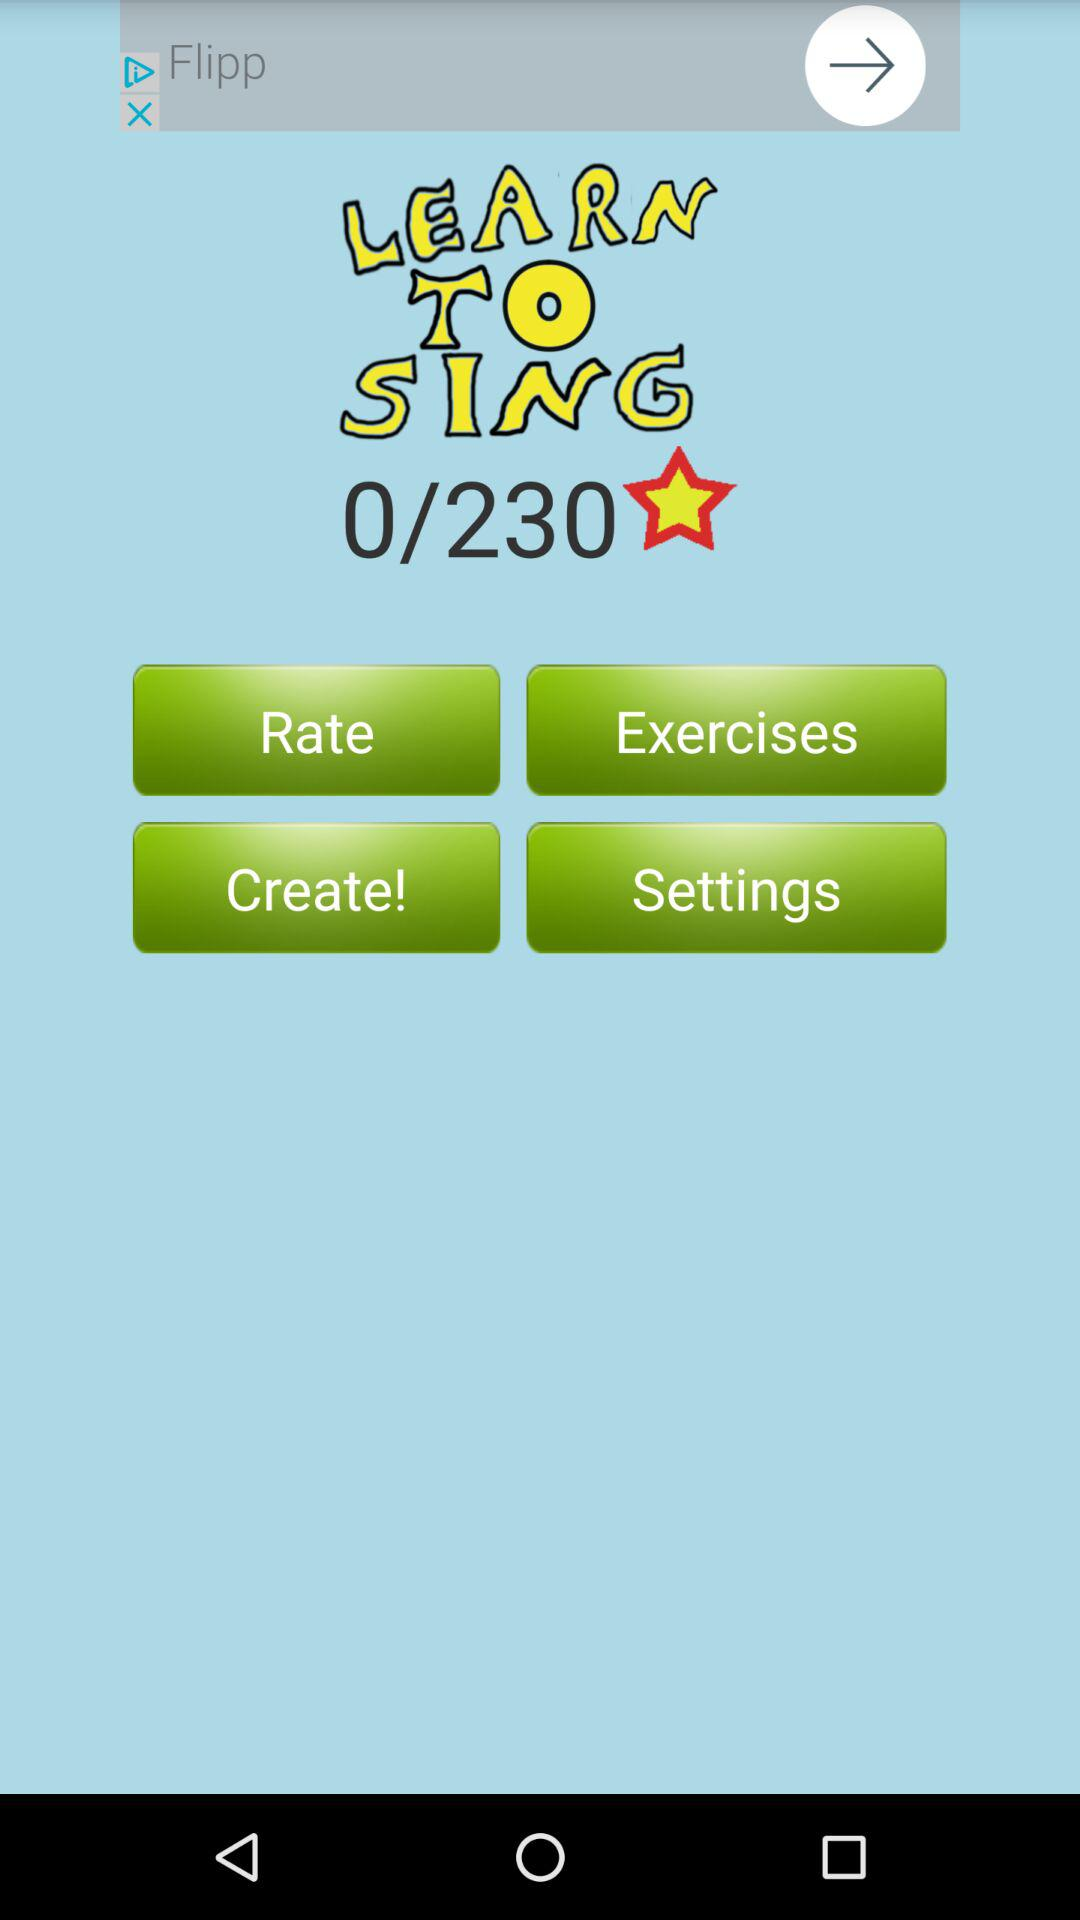How many more exercises do I need to complete?
Answer the question using a single word or phrase. 230 